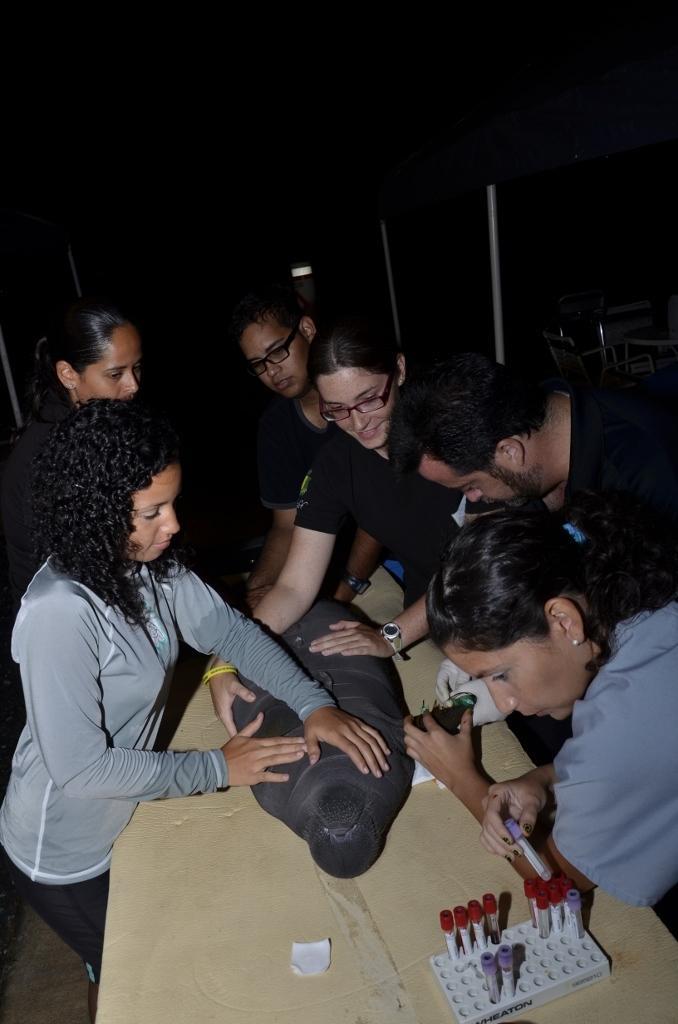Could you give a brief overview of what you see in this image? In this image I can see the group of people standing with something on the table. 